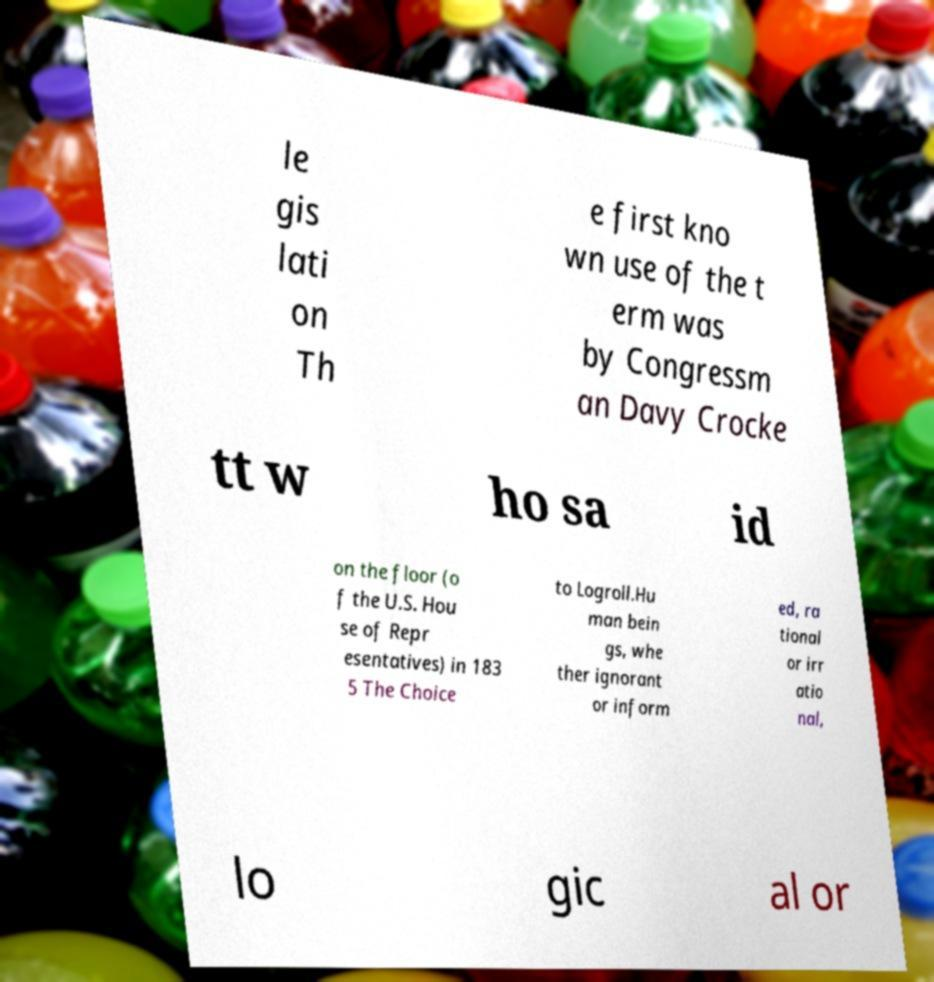Please read and relay the text visible in this image. What does it say? le gis lati on Th e first kno wn use of the t erm was by Congressm an Davy Crocke tt w ho sa id on the floor (o f the U.S. Hou se of Repr esentatives) in 183 5 The Choice to Logroll.Hu man bein gs, whe ther ignorant or inform ed, ra tional or irr atio nal, lo gic al or 